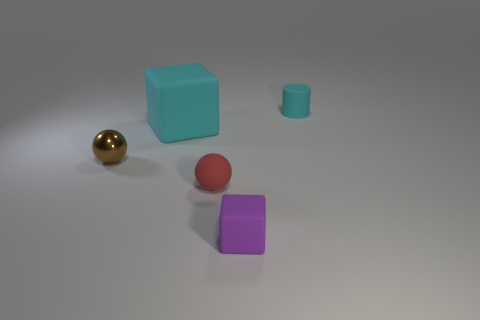Add 3 big red cylinders. How many objects exist? 8 Subtract all cubes. How many objects are left? 3 Subtract all small cyan rubber objects. Subtract all red matte things. How many objects are left? 3 Add 5 tiny rubber objects. How many tiny rubber objects are left? 8 Add 5 tiny brown balls. How many tiny brown balls exist? 6 Subtract 0 blue balls. How many objects are left? 5 